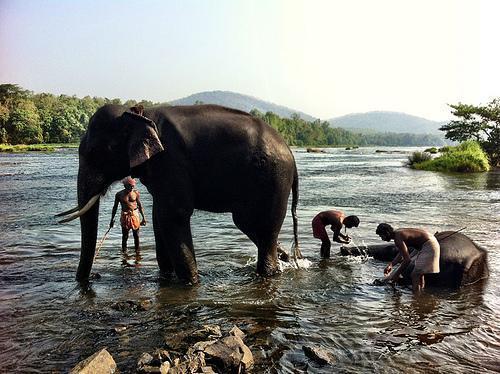How many people in the river?
Give a very brief answer. 3. How many people are washing elephants?
Give a very brief answer. 2. 